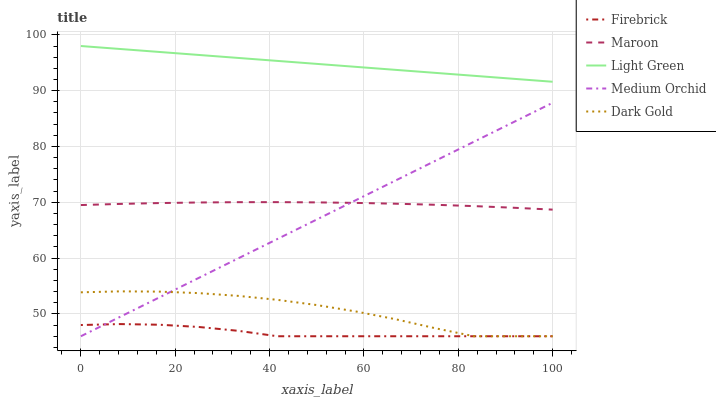Does Medium Orchid have the minimum area under the curve?
Answer yes or no. No. Does Medium Orchid have the maximum area under the curve?
Answer yes or no. No. Is Medium Orchid the smoothest?
Answer yes or no. No. Is Medium Orchid the roughest?
Answer yes or no. No. Does Light Green have the lowest value?
Answer yes or no. No. Does Medium Orchid have the highest value?
Answer yes or no. No. Is Firebrick less than Maroon?
Answer yes or no. Yes. Is Light Green greater than Dark Gold?
Answer yes or no. Yes. Does Firebrick intersect Maroon?
Answer yes or no. No. 